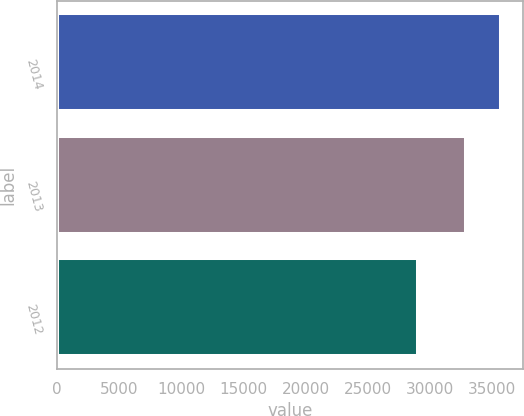Convert chart to OTSL. <chart><loc_0><loc_0><loc_500><loc_500><bar_chart><fcel>2014<fcel>2013<fcel>2012<nl><fcel>35731<fcel>32907<fcel>29039<nl></chart> 